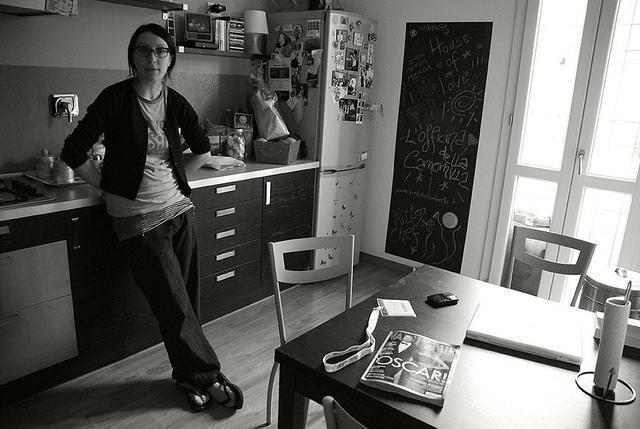Excellence in the American and International film industry award is what?
Answer the question by selecting the correct answer among the 4 following choices.
Options: Cambridge, oscar, national, oxford. Oscar. 